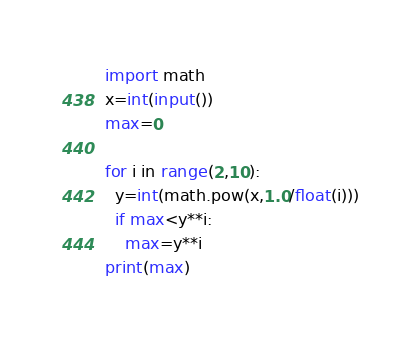<code> <loc_0><loc_0><loc_500><loc_500><_Python_>import math
x=int(input())
max=0

for i in range(2,10):
  y=int(math.pow(x,1.0/float(i)))
  if max<y**i:
    max=y**i
print(max)
</code> 